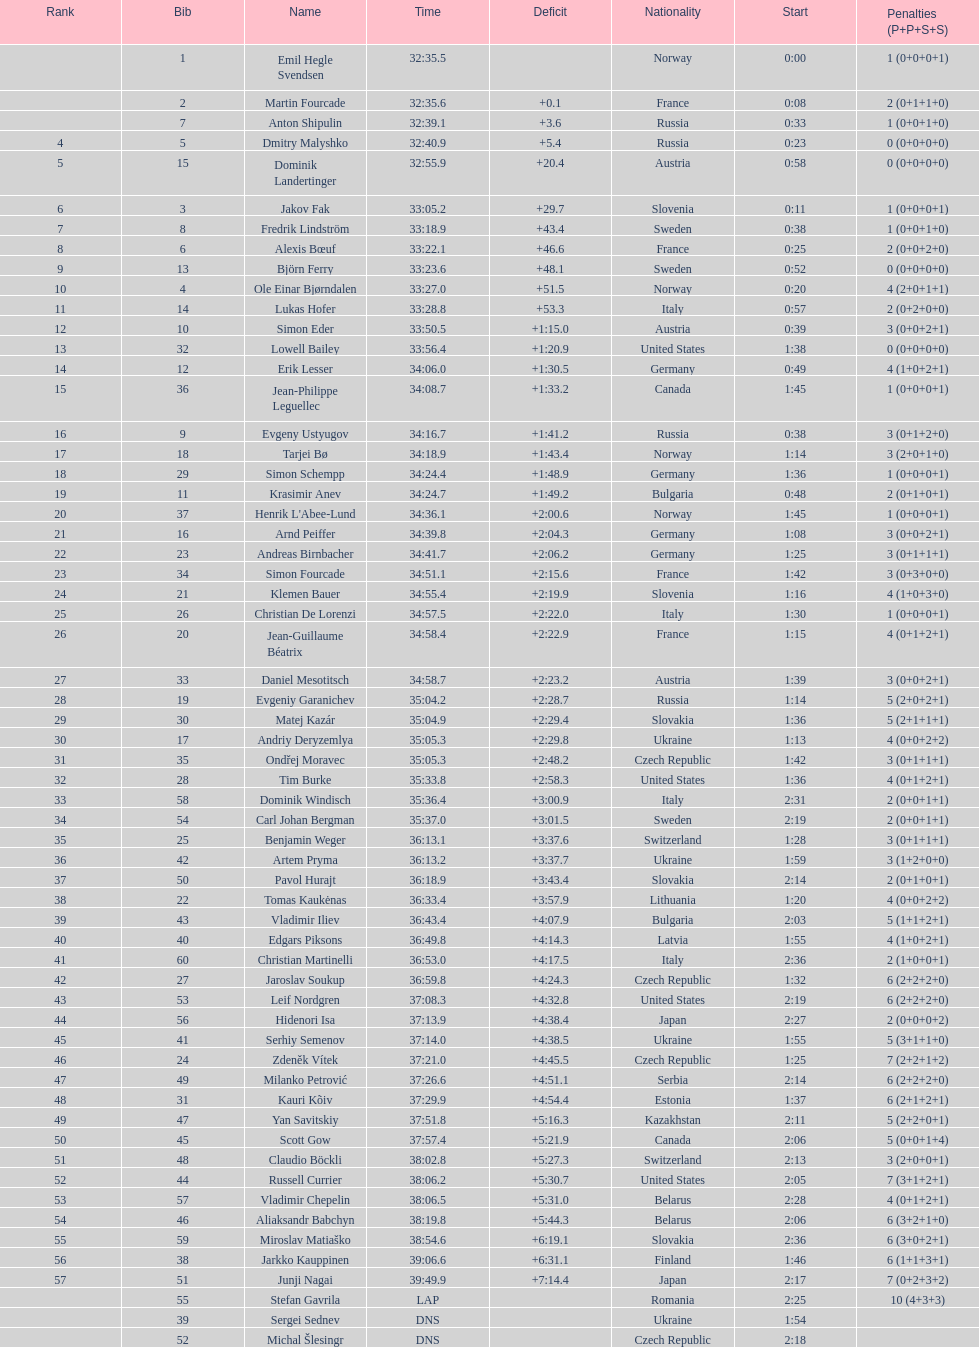How many required 35:00 or more to finish? 30. 